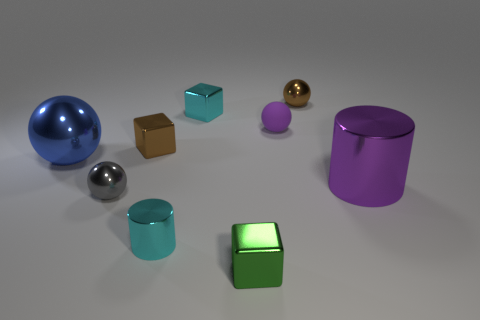What materials do the objects in the image appear to be made of? The objects in the image have a shiny, reflective surface, suggesting that they are made of some kind of metal or have a metallic finish. 